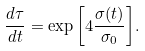<formula> <loc_0><loc_0><loc_500><loc_500>\frac { d \tau } { d t } = \exp { \left [ 4 \frac { \sigma ( t ) } { \sigma _ { 0 } } \right ] } .</formula> 